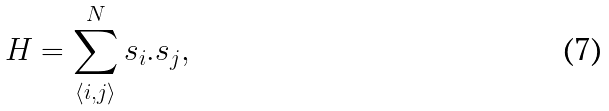<formula> <loc_0><loc_0><loc_500><loc_500>H = \sum _ { \langle i , j \rangle } ^ { N } { s } _ { i } . { s } _ { j } ,</formula> 